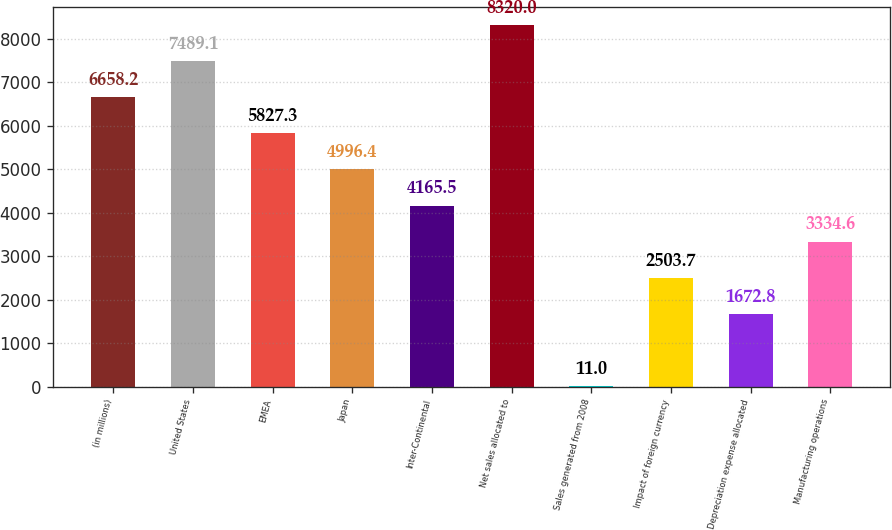Convert chart to OTSL. <chart><loc_0><loc_0><loc_500><loc_500><bar_chart><fcel>(in millions)<fcel>United States<fcel>EMEA<fcel>Japan<fcel>Inter-Continental<fcel>Net sales allocated to<fcel>Sales generated from 2008<fcel>Impact of foreign currency<fcel>Depreciation expense allocated<fcel>Manufacturing operations<nl><fcel>6658.2<fcel>7489.1<fcel>5827.3<fcel>4996.4<fcel>4165.5<fcel>8320<fcel>11<fcel>2503.7<fcel>1672.8<fcel>3334.6<nl></chart> 